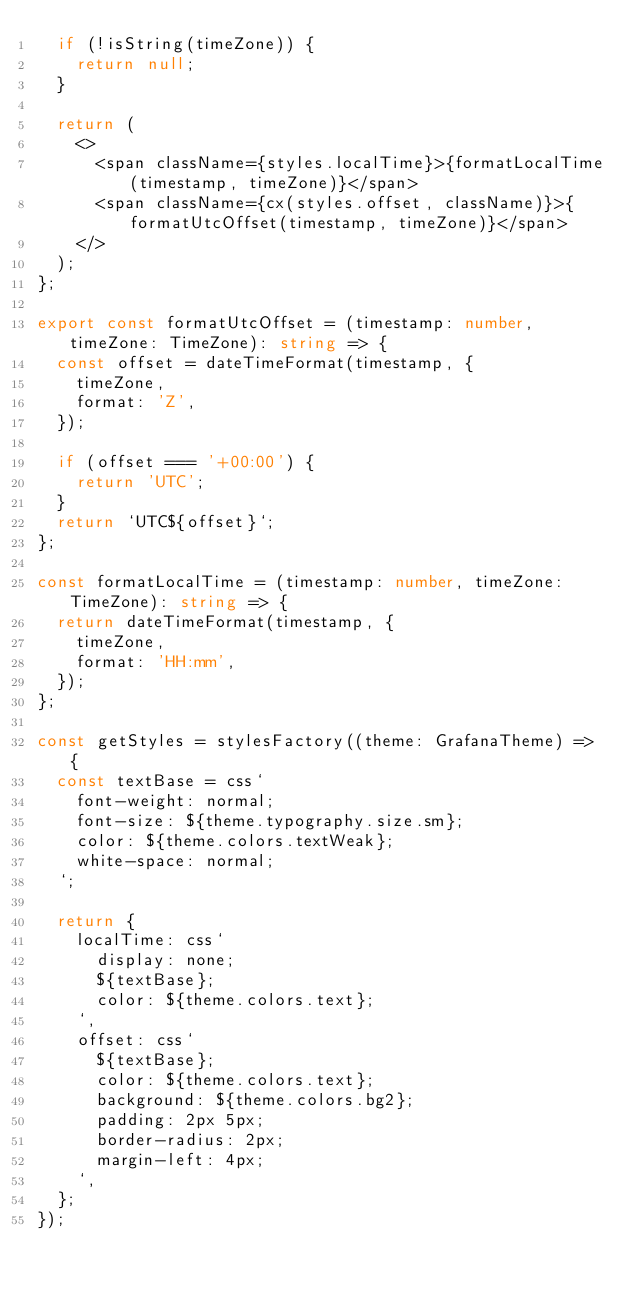Convert code to text. <code><loc_0><loc_0><loc_500><loc_500><_TypeScript_>  if (!isString(timeZone)) {
    return null;
  }

  return (
    <>
      <span className={styles.localTime}>{formatLocalTime(timestamp, timeZone)}</span>
      <span className={cx(styles.offset, className)}>{formatUtcOffset(timestamp, timeZone)}</span>
    </>
  );
};

export const formatUtcOffset = (timestamp: number, timeZone: TimeZone): string => {
  const offset = dateTimeFormat(timestamp, {
    timeZone,
    format: 'Z',
  });

  if (offset === '+00:00') {
    return 'UTC';
  }
  return `UTC${offset}`;
};

const formatLocalTime = (timestamp: number, timeZone: TimeZone): string => {
  return dateTimeFormat(timestamp, {
    timeZone,
    format: 'HH:mm',
  });
};

const getStyles = stylesFactory((theme: GrafanaTheme) => {
  const textBase = css`
    font-weight: normal;
    font-size: ${theme.typography.size.sm};
    color: ${theme.colors.textWeak};
    white-space: normal;
  `;

  return {
    localTime: css`
      display: none;
      ${textBase};
      color: ${theme.colors.text};
    `,
    offset: css`
      ${textBase};
      color: ${theme.colors.text};
      background: ${theme.colors.bg2};
      padding: 2px 5px;
      border-radius: 2px;
      margin-left: 4px;
    `,
  };
});
</code> 